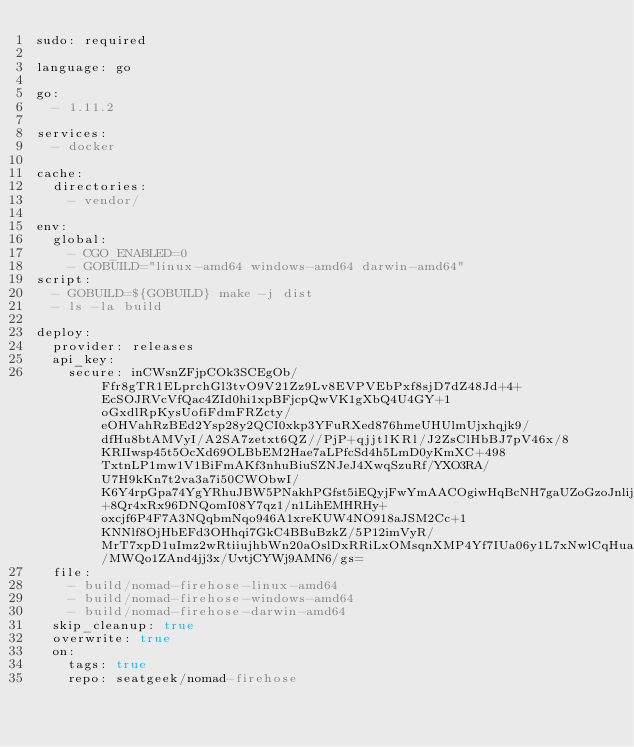<code> <loc_0><loc_0><loc_500><loc_500><_YAML_>sudo: required

language: go

go:
  - 1.11.2

services:
  - docker

cache:
  directories:
    - vendor/

env:
  global:
    - CGO_ENABLED=0
    - GOBUILD="linux-amd64 windows-amd64 darwin-amd64"
script:
  - GOBUILD=${GOBUILD} make -j dist
  - ls -la build

deploy:
  provider: releases
  api_key:
    secure: inCWsnZFjpCOk3SCEgOb/Ffr8gTR1ELprchGl3tvO9V21Zz9Lv8EVPVEbPxf8sjD7dZ48Jd+4+EcSOJRVcVfQac4ZId0hi1xpBFjcpQwVK1gXbQ4U4GY+1oGxdlRpKysUofiFdmFRZcty/eOHVahRzBEd2Ysp28y2QCI0xkp3YFuRXed876hmeUHUlmUjxhqjk9/dfHu8btAMVyI/A2SA7zetxt6QZ//PjP+qjjtlKRl/J2ZsClHbBJ7pV46x/8KRIIwsp45t5OcXd69OLBbEM2Hae7aLPfcSd4h5LmD0yKmXC+498TxtnLP1mw1V1BiFmAKf3nhuBiuSZNJeJ4XwqSzuRf/YXO3RA/U7H9kKn7t2va3a7i50CWObwI/K6Y4rpGpa74YgYRhuJBW5PNakhPGfst5iEQyjFwYmAACOgiwHqBcNH7gaUZoGzoJnlijHWm98v+8Qr4xRx96DNQomI08Y7qz1/n1LihEMHRHy+oxcjf6P4F7A3NQqbmNqo946A1xreKUW4NO918aJSM2Cc+1KNNlf8OjHbEFd3OHhqi7GkC4BBuBzkZ/5P12imVyR/MrT7xpD1uImz2wRtiiujhbWn20aOslDxRRiLxOMsqnXMP4Yf7IUa06y1L7xNwlCqHuaRordP9/MWQo1ZAnd4jj3x/UvtjCYWj9AMN6/gs=
  file:
    - build/nomad-firehose-linux-amd64
    - build/nomad-firehose-windows-amd64
    - build/nomad-firehose-darwin-amd64
  skip_cleanup: true
  overwrite: true
  on:
    tags: true
    repo: seatgeek/nomad-firehose
</code> 